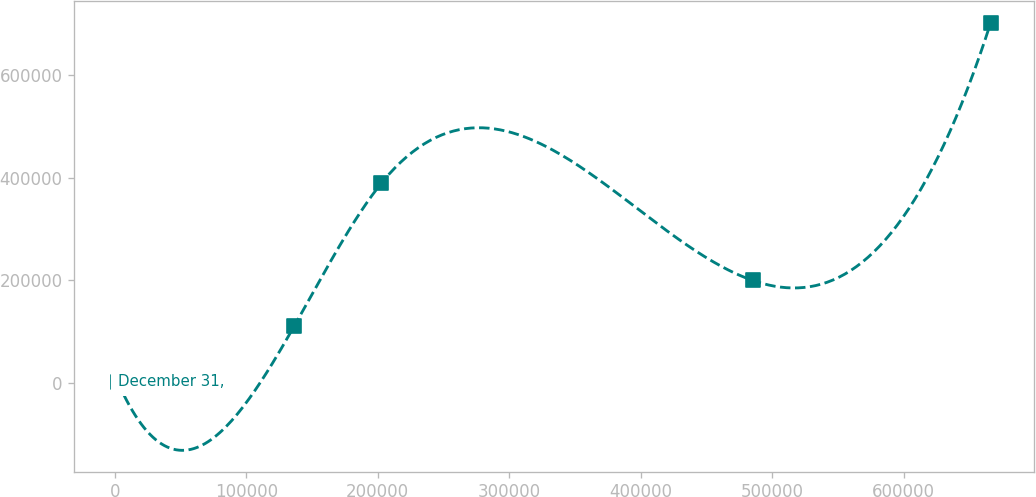<chart> <loc_0><loc_0><loc_500><loc_500><line_chart><ecel><fcel>December 31,<nl><fcel>2356.57<fcel>1979.5<nl><fcel>136443<fcel>110701<nl><fcel>202828<fcel>389835<nl><fcel>485133<fcel>200058<nl><fcel>666206<fcel>703127<nl></chart> 